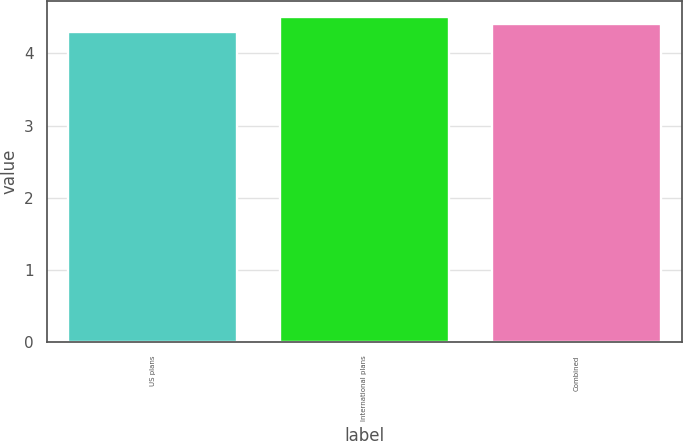Convert chart to OTSL. <chart><loc_0><loc_0><loc_500><loc_500><bar_chart><fcel>US plans<fcel>International plans<fcel>Combined<nl><fcel>4.3<fcel>4.5<fcel>4.4<nl></chart> 